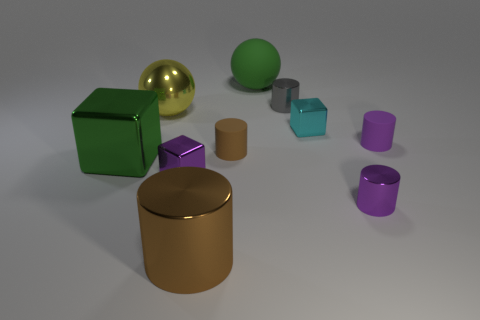Subtract all purple matte cylinders. How many cylinders are left? 4 Subtract all gray cylinders. How many cylinders are left? 4 Subtract 2 cylinders. How many cylinders are left? 3 Subtract all gray cylinders. Subtract all purple spheres. How many cylinders are left? 4 Subtract all blocks. How many objects are left? 7 Subtract 0 red cylinders. How many objects are left? 10 Subtract all big brown objects. Subtract all big green metallic objects. How many objects are left? 8 Add 6 cyan metal objects. How many cyan metal objects are left? 7 Add 7 purple blocks. How many purple blocks exist? 8 